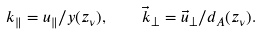Convert formula to latex. <formula><loc_0><loc_0><loc_500><loc_500>k _ { \| } = u _ { \| } / y ( z _ { \nu } ) , \quad \vec { k } _ { \perp } = \vec { u } _ { \perp } / d _ { A } ( z _ { \nu } ) .</formula> 